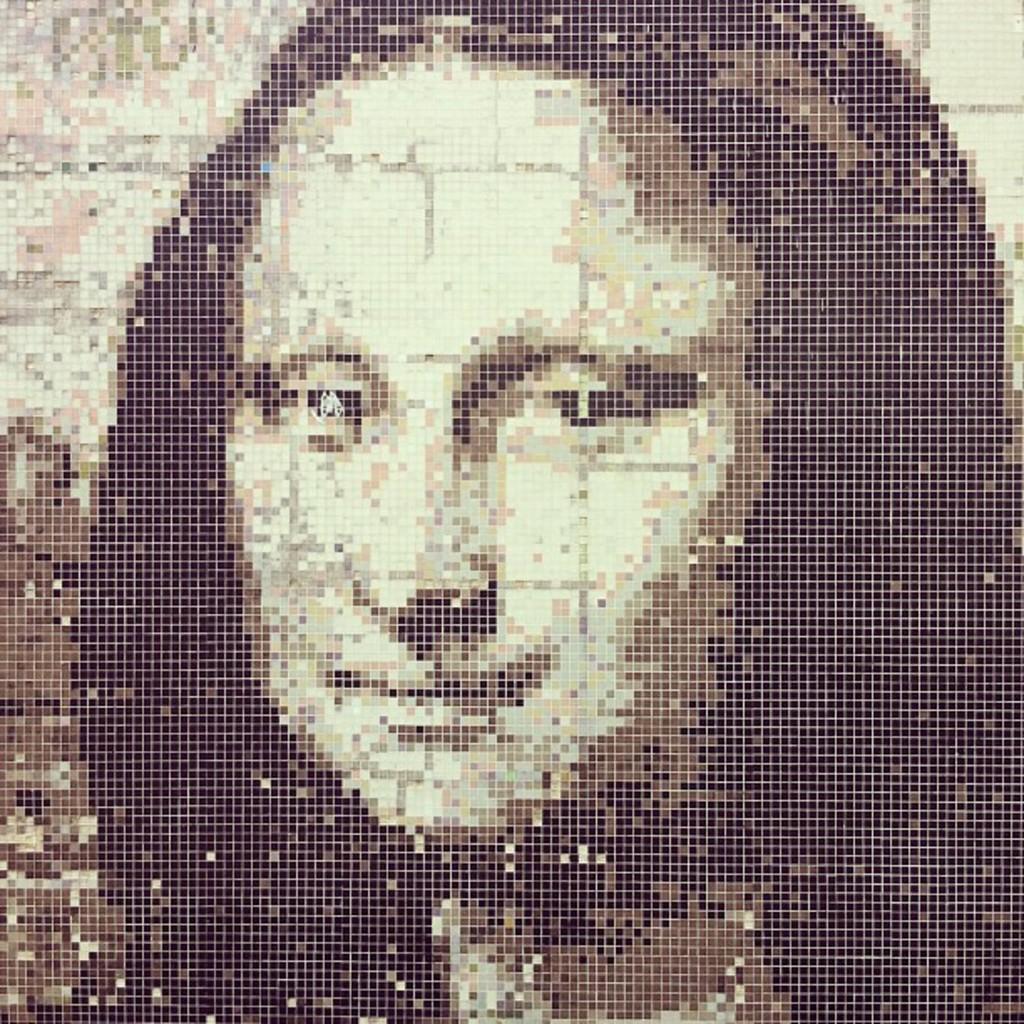Please provide a concise description of this image. This is an edited image. In this image we can see a woman. 